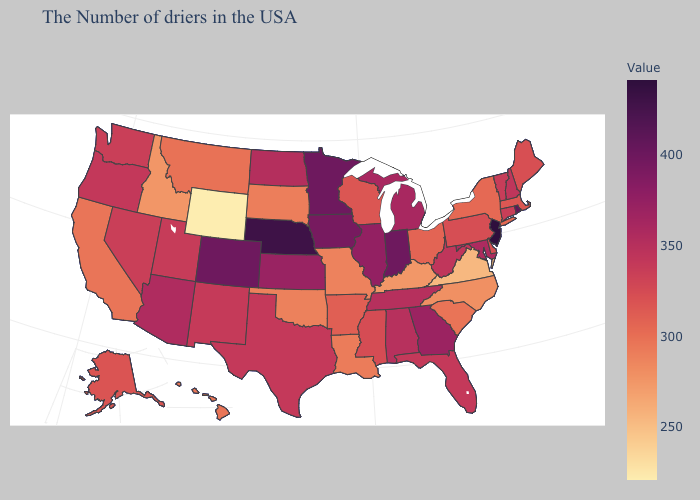Does Illinois have a lower value than Nebraska?
Short answer required. Yes. Does Nebraska have a lower value than Louisiana?
Quick response, please. No. Does Missouri have the highest value in the MidWest?
Short answer required. No. Does Hawaii have the lowest value in the West?
Write a very short answer. No. Which states have the highest value in the USA?
Keep it brief. New Jersey. Does South Carolina have a higher value than Georgia?
Keep it brief. No. 